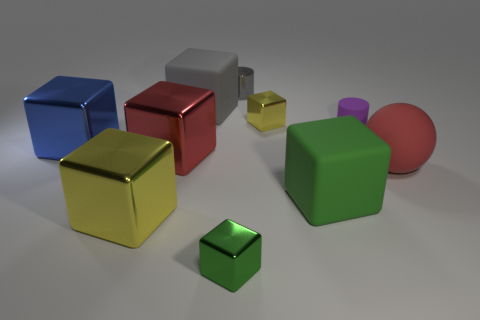Subtract all large red metallic cubes. How many cubes are left? 6 Subtract all blue blocks. How many blocks are left? 6 Subtract all green cubes. Subtract all cyan cylinders. How many cubes are left? 5 Subtract all spheres. How many objects are left? 9 Add 8 big green things. How many big green things are left? 9 Add 6 tiny green metal cylinders. How many tiny green metal cylinders exist? 6 Subtract 0 cyan cylinders. How many objects are left? 10 Subtract all small shiny objects. Subtract all tiny cubes. How many objects are left? 5 